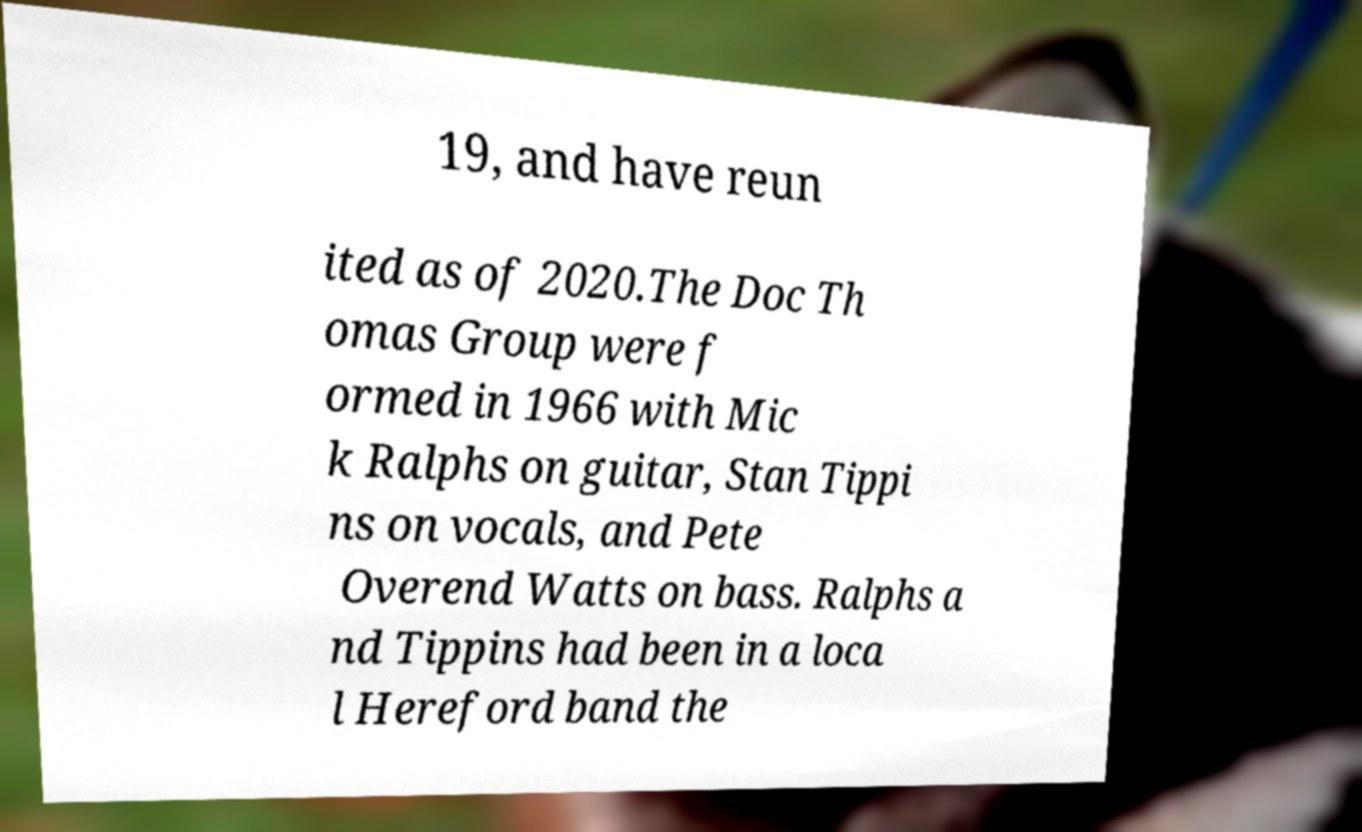Please read and relay the text visible in this image. What does it say? 19, and have reun ited as of 2020.The Doc Th omas Group were f ormed in 1966 with Mic k Ralphs on guitar, Stan Tippi ns on vocals, and Pete Overend Watts on bass. Ralphs a nd Tippins had been in a loca l Hereford band the 